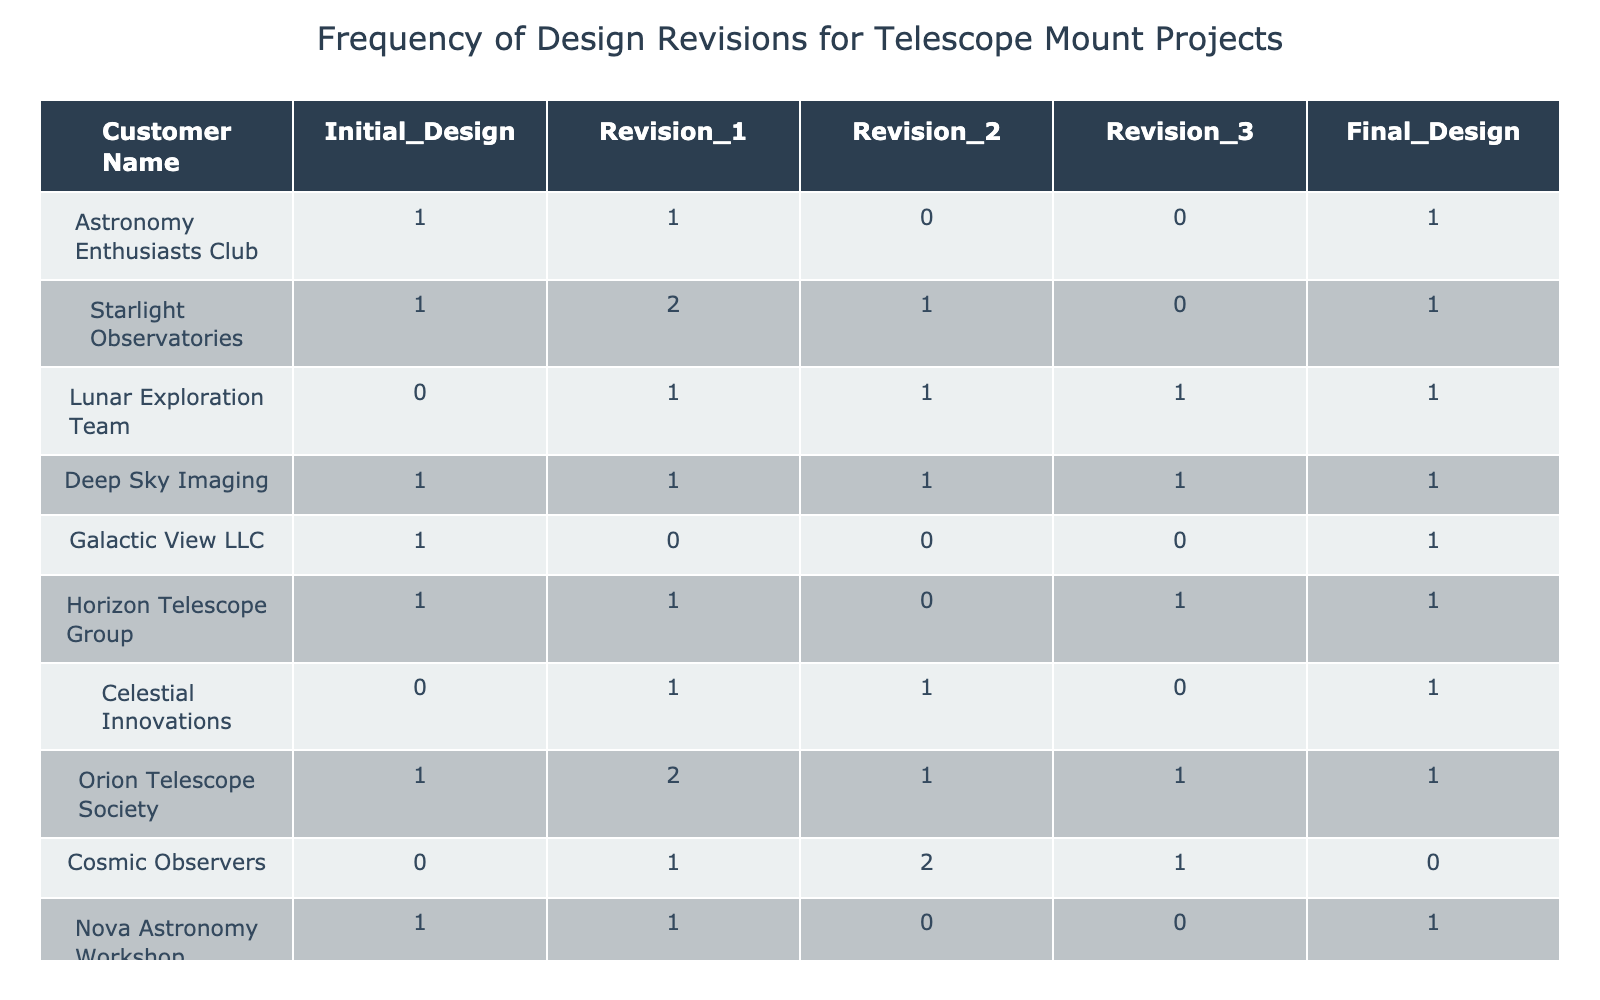What is the total number of revisions made by the Lunar Exploration Team? The data for the Lunar Exploration Team shows revisions as follows: Revision 1 is 1, Revision 2 is 1, and Revision 3 is 1. Adding these together gives 1 + 1 + 1 = 3.
Answer: 3 How many customers had a final design that did not require any revisions? Looking at the final design column, the customers with a final design of 1 (no revisions) are Galactic View LLC and Cosmic Observers, which makes a total of 2 customers.
Answer: 2 What is the average number of revisions across all customers who designed telescope mounts? First, sum the total number of revisions for all customers: (1+1+1) + (2+1) + (1+1+1) + (1+0) + (1+1+0+1) + (1+1) + (1+2+1) + (1+0) = 13. There are 10 customers, so the average is 13 / 10 = 1.3.
Answer: 1.3 Did Starlight Observatories have more revisions than Cosmic Observers? For Starlight Observatories, the total revisions are 2 (Revision 1) + 1 (Revision 2) = 3. For Cosmic Observers, the total revisions are 1 (Revision 1) + 2 (Revision 2) + 1 (Revision 3) = 4. Since 3 is less than 4, the answer is no.
Answer: No Which customer made the maximum number of revisions? By reviewing the data, the revisions for each customer are: Deep Sky Imaging (4), Lunar Exploration Team (3), Orion Telescope Society (4), and others lower. The maximum of 4 is shared by Deep Sky Imaging and Orion Telescope Society, hence either one is correct.
Answer: Deep Sky Imaging and Orion Telescope Society How many customers only required one revision in their design process? From the data, check each customer: Astronomy Enthusiasts Club (1), Galactic View LLC (0), Nova Astronomy Workshop (1), and others. The customers with only 1 revision are Astronomy Enthusiasts Club and Nova Astronomy Workshop. The total is 2 customers.
Answer: 2 Did any customer have a final design with zero revisions? Inspecting the table, Cosmic Observers has a final design of 0, which indeed indicates no revisions. Therefore, the answer is yes.
Answer: Yes What is the combined total of all revisions made by the Horizon Telescope Group? For Horizon Telescope Group, the revisions are 1 (Revision 1) + 0 (Revision 2) + 1 (Revision 3) = 2. The combined total for the customer is therefore 2.
Answer: 2 How many customers had two or more revisions before arriving at the final design? Customers who had 2 or more revisions are: Starlight Observatories (2), Orion Telescope Society (2), Lunar Exploration Team (2), and Deep Sky Imaging (4). Therefore, the total is 4 customers.
Answer: 4 